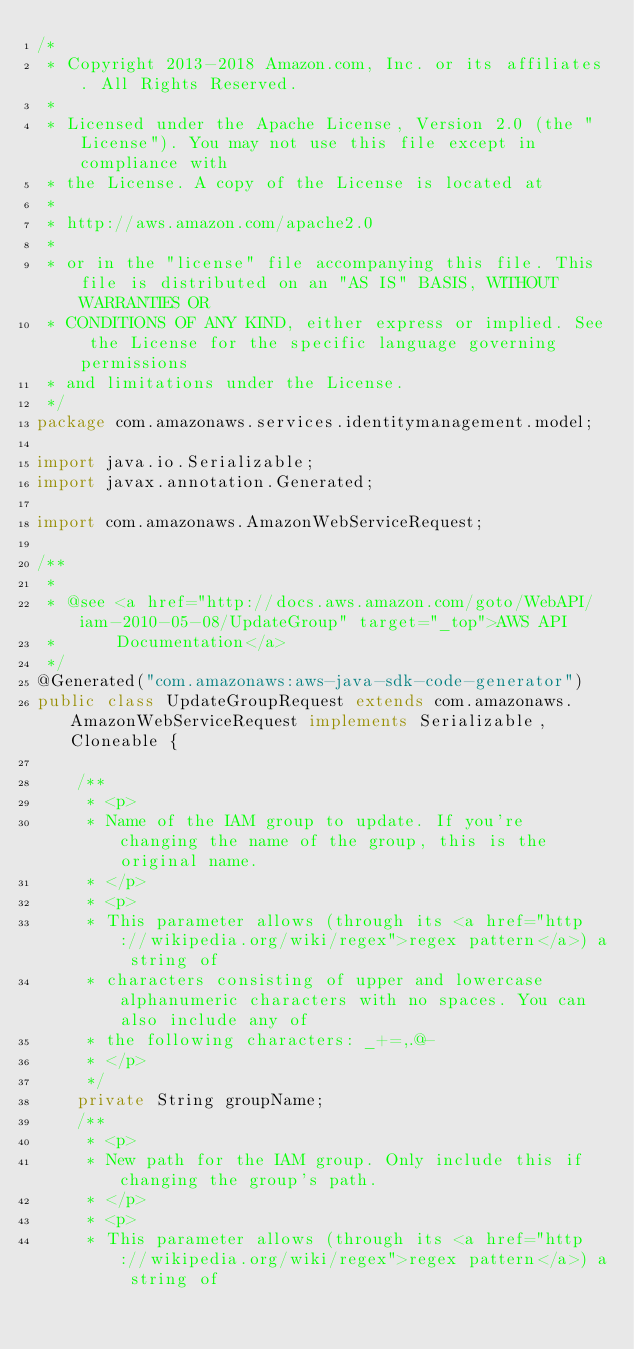<code> <loc_0><loc_0><loc_500><loc_500><_Java_>/*
 * Copyright 2013-2018 Amazon.com, Inc. or its affiliates. All Rights Reserved.
 * 
 * Licensed under the Apache License, Version 2.0 (the "License"). You may not use this file except in compliance with
 * the License. A copy of the License is located at
 * 
 * http://aws.amazon.com/apache2.0
 * 
 * or in the "license" file accompanying this file. This file is distributed on an "AS IS" BASIS, WITHOUT WARRANTIES OR
 * CONDITIONS OF ANY KIND, either express or implied. See the License for the specific language governing permissions
 * and limitations under the License.
 */
package com.amazonaws.services.identitymanagement.model;

import java.io.Serializable;
import javax.annotation.Generated;

import com.amazonaws.AmazonWebServiceRequest;

/**
 * 
 * @see <a href="http://docs.aws.amazon.com/goto/WebAPI/iam-2010-05-08/UpdateGroup" target="_top">AWS API
 *      Documentation</a>
 */
@Generated("com.amazonaws:aws-java-sdk-code-generator")
public class UpdateGroupRequest extends com.amazonaws.AmazonWebServiceRequest implements Serializable, Cloneable {

    /**
     * <p>
     * Name of the IAM group to update. If you're changing the name of the group, this is the original name.
     * </p>
     * <p>
     * This parameter allows (through its <a href="http://wikipedia.org/wiki/regex">regex pattern</a>) a string of
     * characters consisting of upper and lowercase alphanumeric characters with no spaces. You can also include any of
     * the following characters: _+=,.@-
     * </p>
     */
    private String groupName;
    /**
     * <p>
     * New path for the IAM group. Only include this if changing the group's path.
     * </p>
     * <p>
     * This parameter allows (through its <a href="http://wikipedia.org/wiki/regex">regex pattern</a>) a string of</code> 